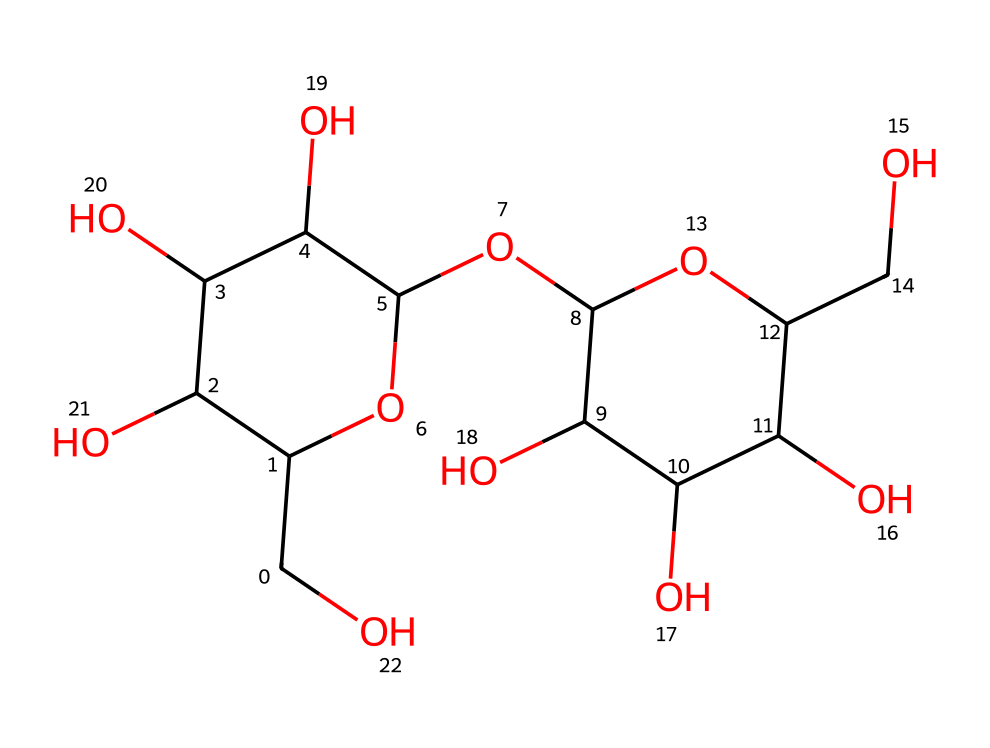How many carbon atoms are in this structure? In the provided SMILES representation, each 'C' denotes a carbon atom. By counting all the 'C' symbols, we find there are 18 carbon atoms in total.
Answer: 18 What type of carbohydrate is represented by this structure? The presence of multiple hydroxyl (-OH) groups and a complex ring structure indicates this chemical is a polysaccharide. Given that it's a storage form of glucose in plants, it is identified as starch.
Answer: starch How many hydroxyl groups are in this molecule? The hydroxyl groups are represented by the 'O' atoms linked with 'H' atoms in the structural representation. Counting these connections leads to the total of 7 hydroxyl groups present in this molecule.
Answer: 7 What is the molecular weight of this compound? To determine the molecular weight, we add the atomic weights of all the constituent atoms: 18 carbon, 32 hydrogen, and 14 oxygen. This calculation yields a molecular weight of approximately 342 grams per mole.
Answer: 342 What linkages are present between the glucose units in starch? The presence of the repeating unit structure, where glucose monomers are connected via glycosidic bonds, specifically alpha-1,4-glycosidic linkages leads us to conclude that this is a characteristic of starch.
Answer: alpha-1,4-glycosidic linkages What does the structure suggest about its solubility in water? The multiple hydroxyl groups create many opportunities for hydrogen bonding with water, indicating that this polysaccharide is likely to be soluble in water, as is characteristic of many carbohydrates.
Answer: soluble in water What role does this compound play in human biology related to the vocal cords? Starch is primarily used as an energy source, but in this context, its molecular composition could suggest a role in providing lubrication for the vocal cords due to its ability to retain water and form a gel-like consistency.
Answer: lubrication 